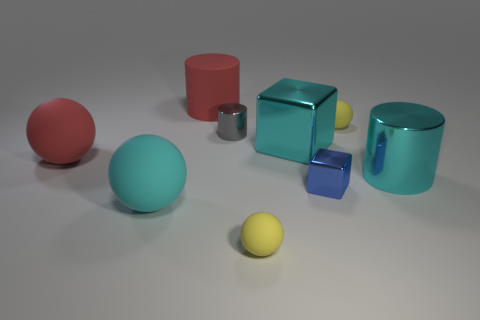What number of objects are either rubber objects that are to the right of the red rubber cylinder or cylinders behind the big cyan cylinder?
Provide a succinct answer. 4. Is the shape of the red rubber thing behind the cyan metallic block the same as the yellow thing in front of the big cyan metallic cube?
Give a very brief answer. No. What is the shape of the other metal object that is the same size as the blue metal thing?
Provide a short and direct response. Cylinder. What number of metal things are large objects or green objects?
Make the answer very short. 2. Is the material of the large red thing in front of the matte cylinder the same as the tiny yellow thing that is in front of the cyan rubber ball?
Offer a very short reply. Yes. There is a small thing that is made of the same material as the blue cube; what is its color?
Provide a short and direct response. Gray. Are there more small matte balls behind the big metallic cylinder than big cyan cylinders that are in front of the blue object?
Keep it short and to the point. Yes. Are any cyan things visible?
Offer a very short reply. Yes. What is the material of the sphere that is the same color as the large matte cylinder?
Your answer should be very brief. Rubber. What number of things are either small gray cylinders or gray matte cylinders?
Offer a terse response. 1. 